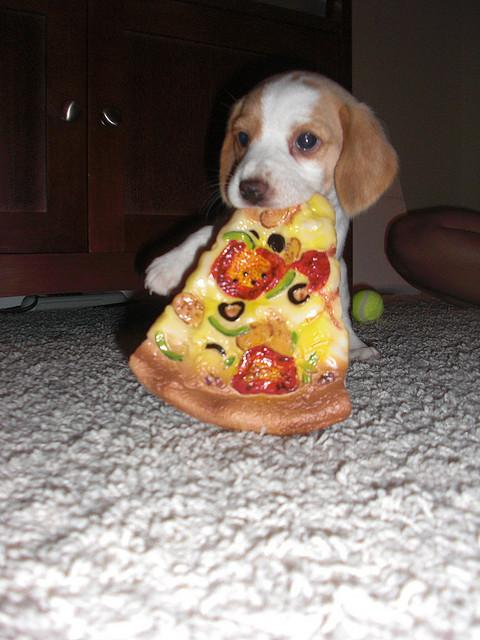What is the dog doing with the thing in its mouth?

Choices:
A) vomiting
B) eating
C) playing
D) choking playing 